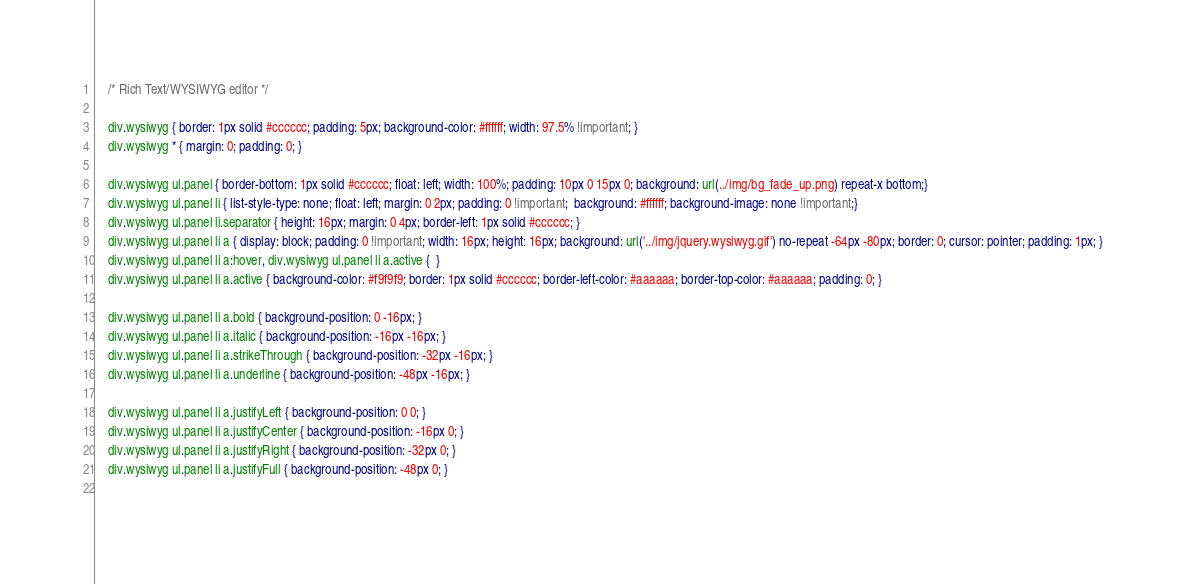<code> <loc_0><loc_0><loc_500><loc_500><_CSS_>	/* Rich Text/WYSIWYG editor */

	div.wysiwyg { border: 1px solid #cccccc; padding: 5px; background-color: #ffffff; width: 97.5% !important; }
	div.wysiwyg * { margin: 0; padding: 0; }
	
	div.wysiwyg ul.panel { border-bottom: 1px solid #cccccc; float: left; width: 100%; padding: 10px 0 15px 0; background: url(../img/bg_fade_up.png) repeat-x bottom;}
	div.wysiwyg ul.panel li { list-style-type: none; float: left; margin: 0 2px; padding: 0 !important;  background: #ffffff; background-image: none !important;}
	div.wysiwyg ul.panel li.separator { height: 16px; margin: 0 4px; border-left: 1px solid #cccccc; }
	div.wysiwyg ul.panel li a { display: block; padding: 0 !important; width: 16px; height: 16px; background: url('../img/jquery.wysiwyg.gif') no-repeat -64px -80px; border: 0; cursor: pointer; padding: 1px; }
	div.wysiwyg ul.panel li a:hover, div.wysiwyg ul.panel li a.active {  }
	div.wysiwyg ul.panel li a.active { background-color: #f9f9f9; border: 1px solid #cccccc; border-left-color: #aaaaaa; border-top-color: #aaaaaa; padding: 0; }
	
	div.wysiwyg ul.panel li a.bold { background-position: 0 -16px; }
	div.wysiwyg ul.panel li a.italic { background-position: -16px -16px; }
	div.wysiwyg ul.panel li a.strikeThrough { background-position: -32px -16px; }
	div.wysiwyg ul.panel li a.underline { background-position: -48px -16px; }
	
	div.wysiwyg ul.panel li a.justifyLeft { background-position: 0 0; }
	div.wysiwyg ul.panel li a.justifyCenter { background-position: -16px 0; }
	div.wysiwyg ul.panel li a.justifyRight { background-position: -32px 0; }
	div.wysiwyg ul.panel li a.justifyFull { background-position: -48px 0; }
	</code> 